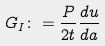Convert formula to latex. <formula><loc_0><loc_0><loc_500><loc_500>G _ { I } \colon = \frac { P } { 2 t } \frac { d u } { d a }</formula> 